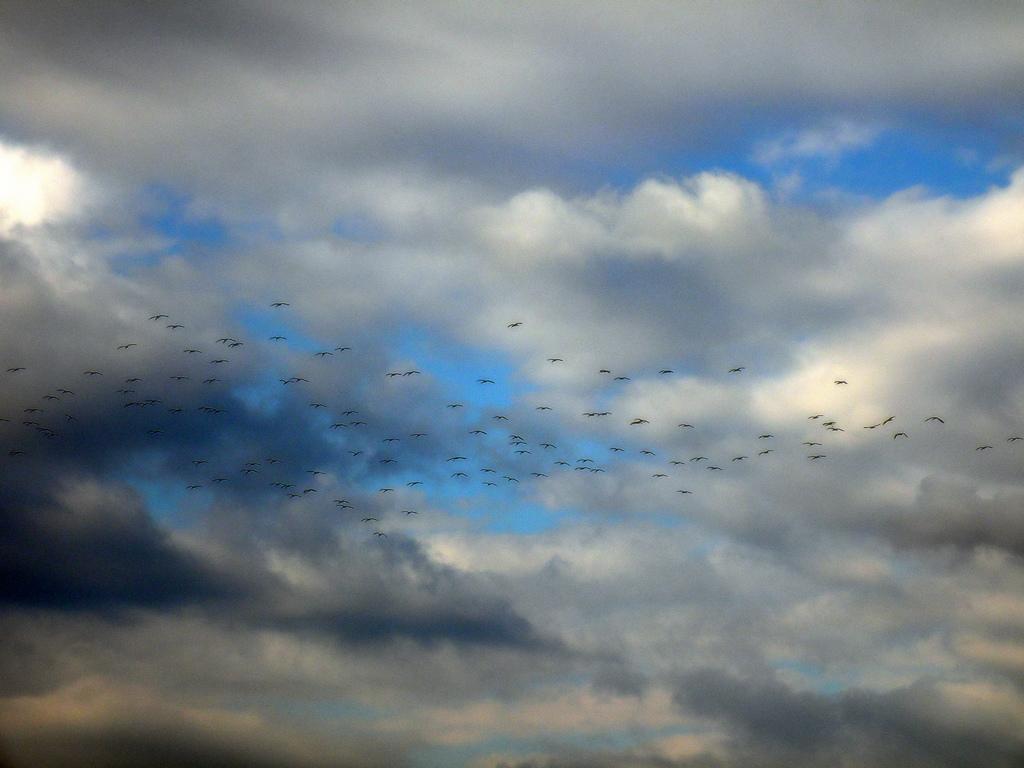Could you give a brief overview of what you see in this image? We can see birds flying in the air and we can see sky is cloudy. 